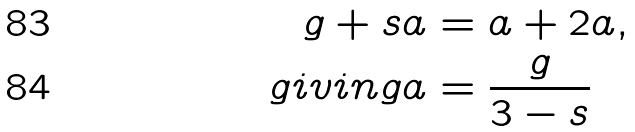<formula> <loc_0><loc_0><loc_500><loc_500>g + s a & = a + 2 a , \\ { g i v i n g } a & = \frac { g } { 3 - s }</formula> 